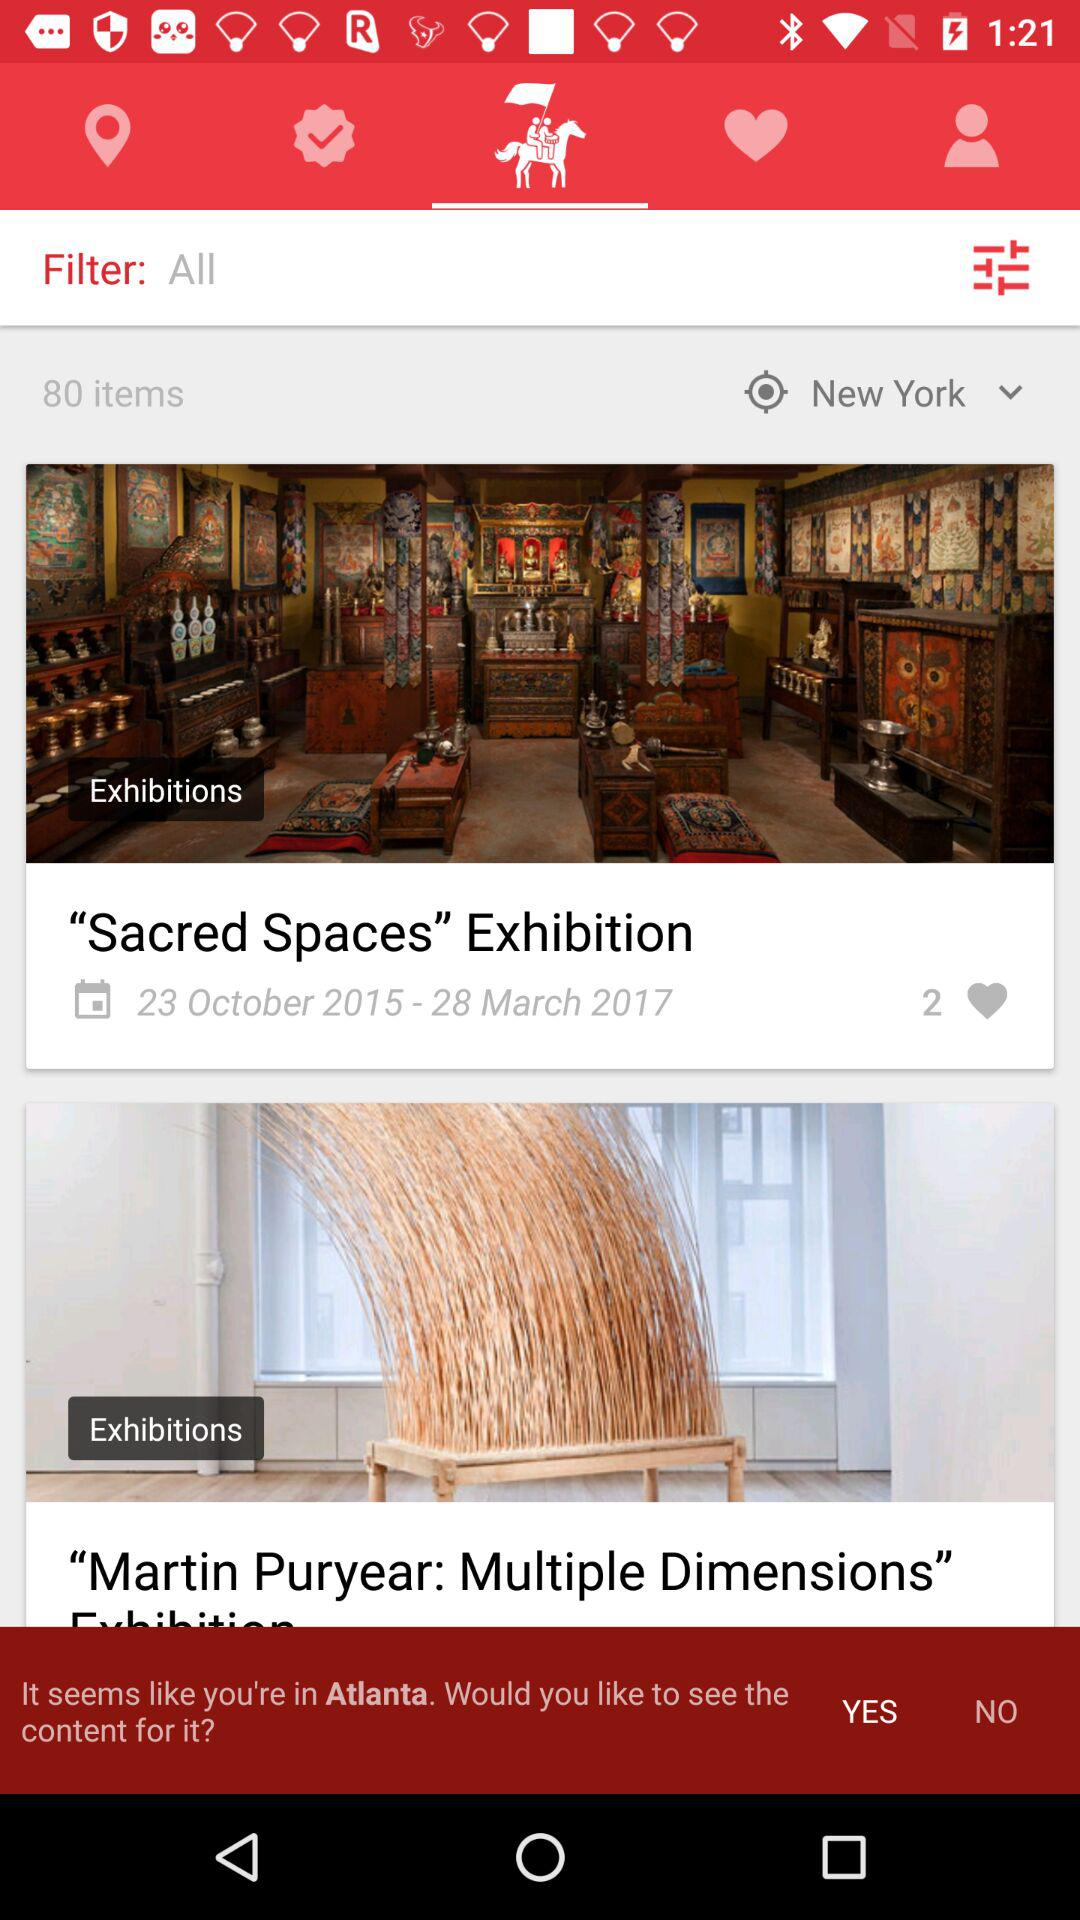How many exhibitions are displayed on the screen?
Answer the question using a single word or phrase. 2 